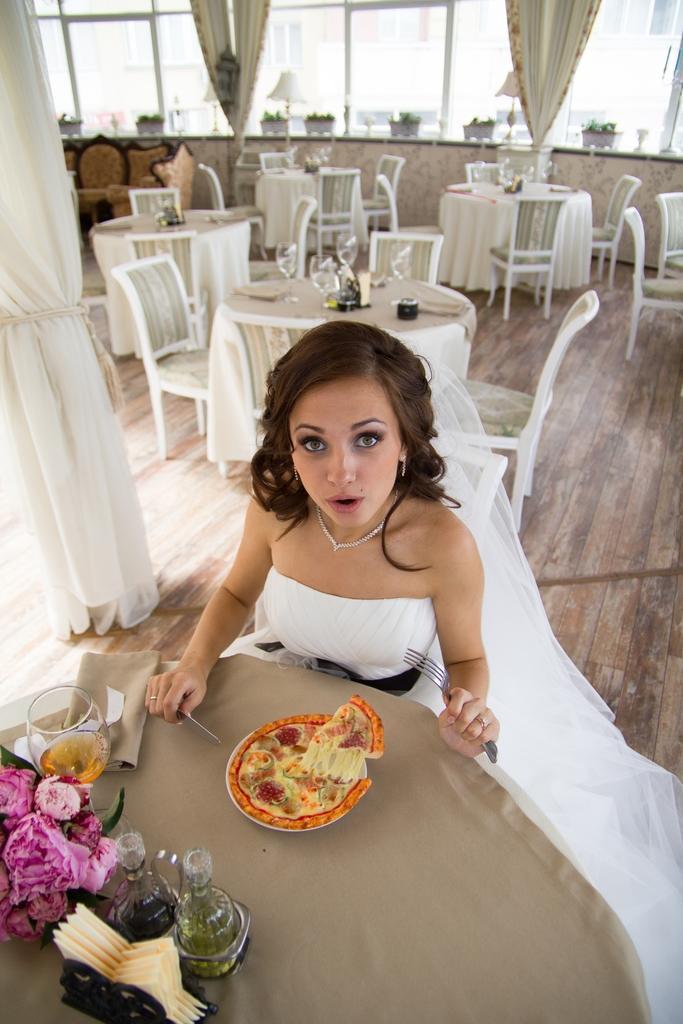Can you describe this image briefly? In this image i can see a lady wear a bride dress sitting in a chair and holding a fork and a spoon in her hands. In front of her there is a table on which there are flower bouquet, wine glass, bottles and a pizza. on the background i can see few empty chairs and tables, curtains, windows and a lamp. 